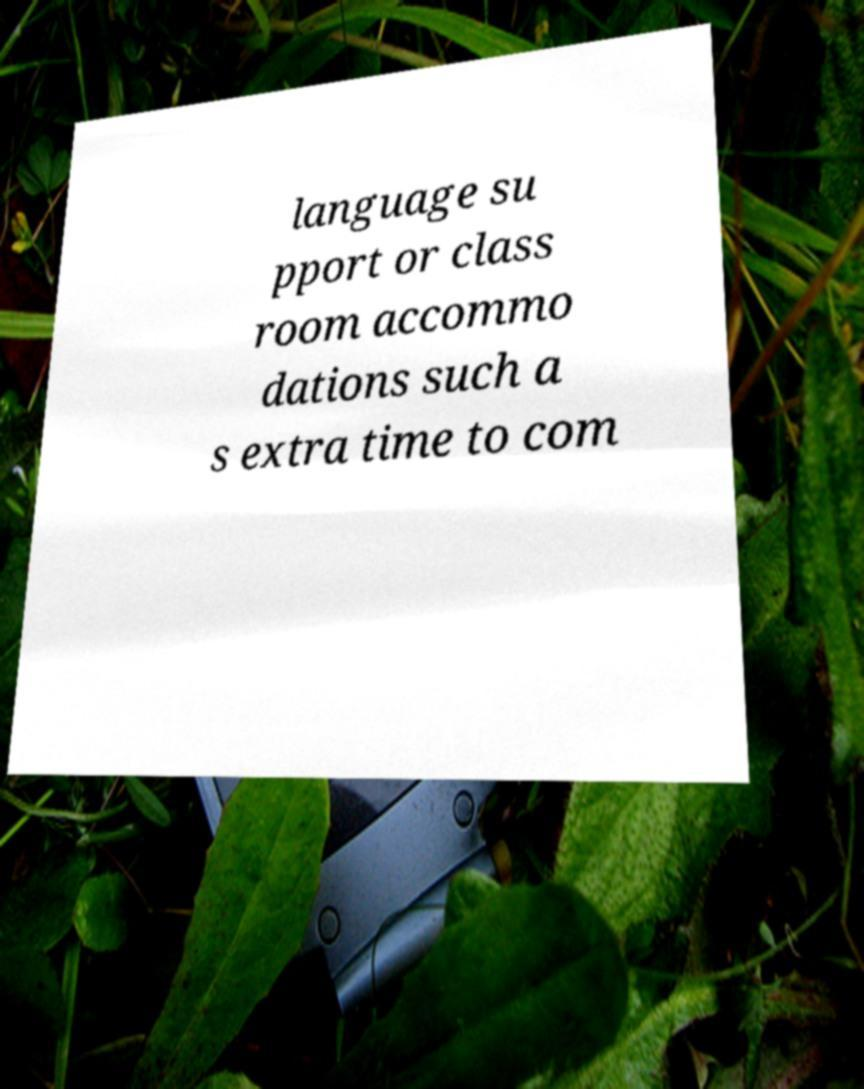Can you accurately transcribe the text from the provided image for me? language su pport or class room accommo dations such a s extra time to com 